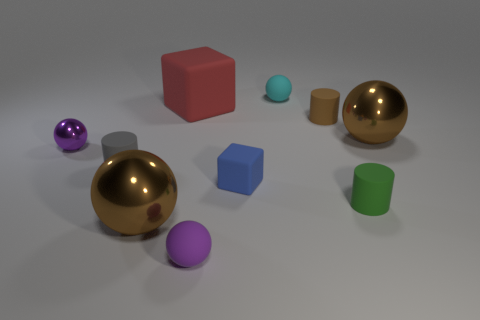How many brown metal objects are there?
Give a very brief answer. 2. What material is the tiny purple thing that is behind the brown metal thing that is on the left side of the tiny purple matte sphere?
Give a very brief answer. Metal. The cylinder that is left of the tiny purple sphere that is on the right side of the big metal object left of the tiny green matte thing is what color?
Offer a very short reply. Gray. Is the large block the same color as the small shiny thing?
Provide a succinct answer. No. What number of brown spheres are the same size as the cyan matte thing?
Make the answer very short. 0. Is the number of metal balls right of the small green thing greater than the number of tiny shiny balls in front of the tiny blue block?
Your response must be concise. Yes. What is the color of the small object that is to the left of the cylinder that is to the left of the large cube?
Keep it short and to the point. Purple. Do the blue cube and the small gray cylinder have the same material?
Give a very brief answer. Yes. Are there any other metallic things that have the same shape as the small shiny thing?
Offer a terse response. Yes. There is a rubber sphere that is on the left side of the blue thing; is it the same color as the small metallic ball?
Ensure brevity in your answer.  Yes. 